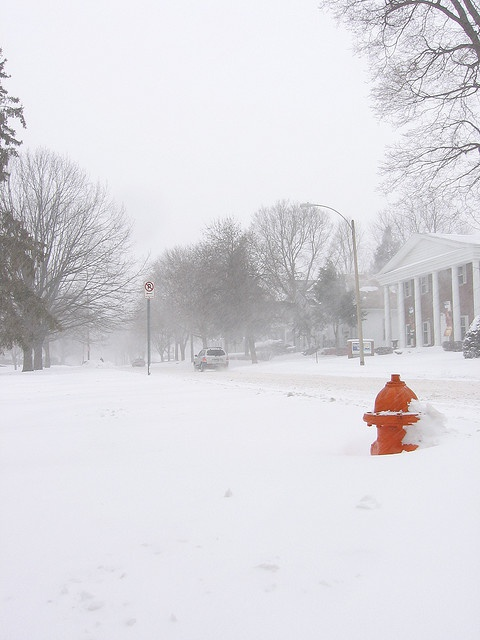Describe the objects in this image and their specific colors. I can see fire hydrant in white, brown, lightgray, and darkgray tones, car in white, darkgray, lightgray, and pink tones, and car in white, darkgray, and lightgray tones in this image. 